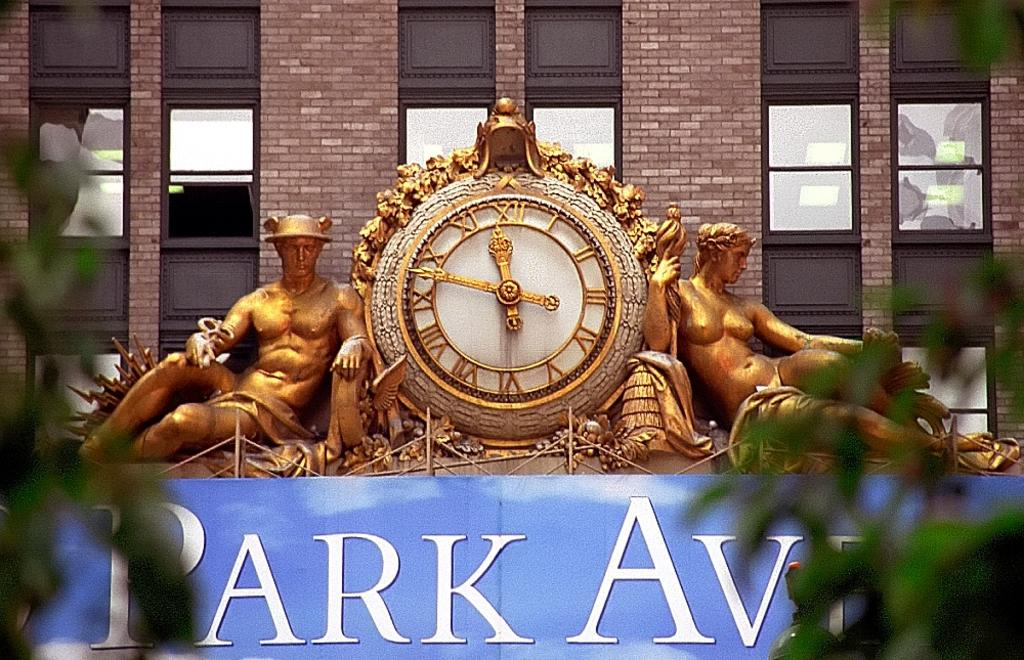<image>
Render a clear and concise summary of the photo. A clock with gold statues sits on a sign for PARK AV. 